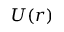<formula> <loc_0><loc_0><loc_500><loc_500>U ( r )</formula> 